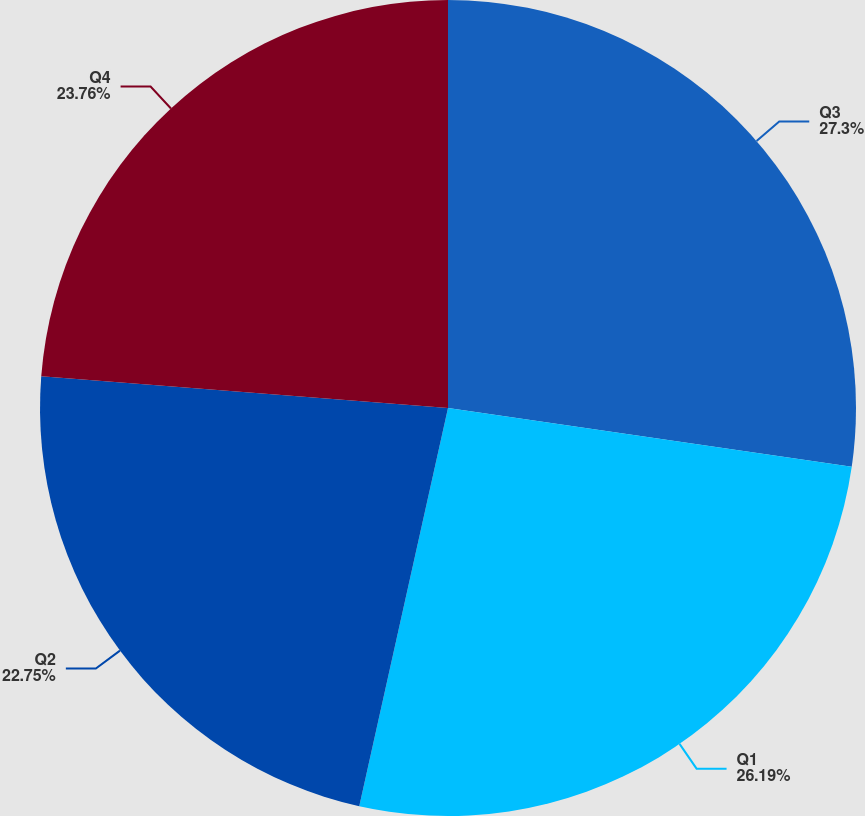<chart> <loc_0><loc_0><loc_500><loc_500><pie_chart><fcel>Q3<fcel>Q1<fcel>Q2<fcel>Q4<nl><fcel>27.3%<fcel>26.19%<fcel>22.75%<fcel>23.76%<nl></chart> 